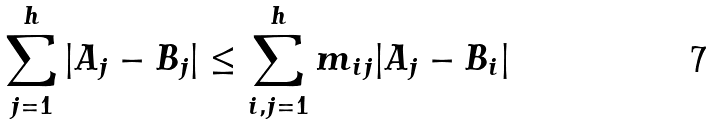<formula> <loc_0><loc_0><loc_500><loc_500>\sum _ { j = 1 } ^ { h } | A _ { j } - B _ { j } | \leq \sum _ { i , j = 1 } ^ { h } m _ { i j } | A _ { j } - B _ { i } |</formula> 